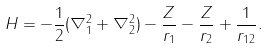Convert formula to latex. <formula><loc_0><loc_0><loc_500><loc_500>H = - \frac { 1 } { 2 } ( \nabla ^ { 2 } _ { 1 } + \nabla ^ { 2 } _ { 2 } ) - \frac { Z } { r _ { 1 } } - \frac { Z } { r _ { 2 } } + \frac { 1 } { r _ { 1 2 } } .</formula> 